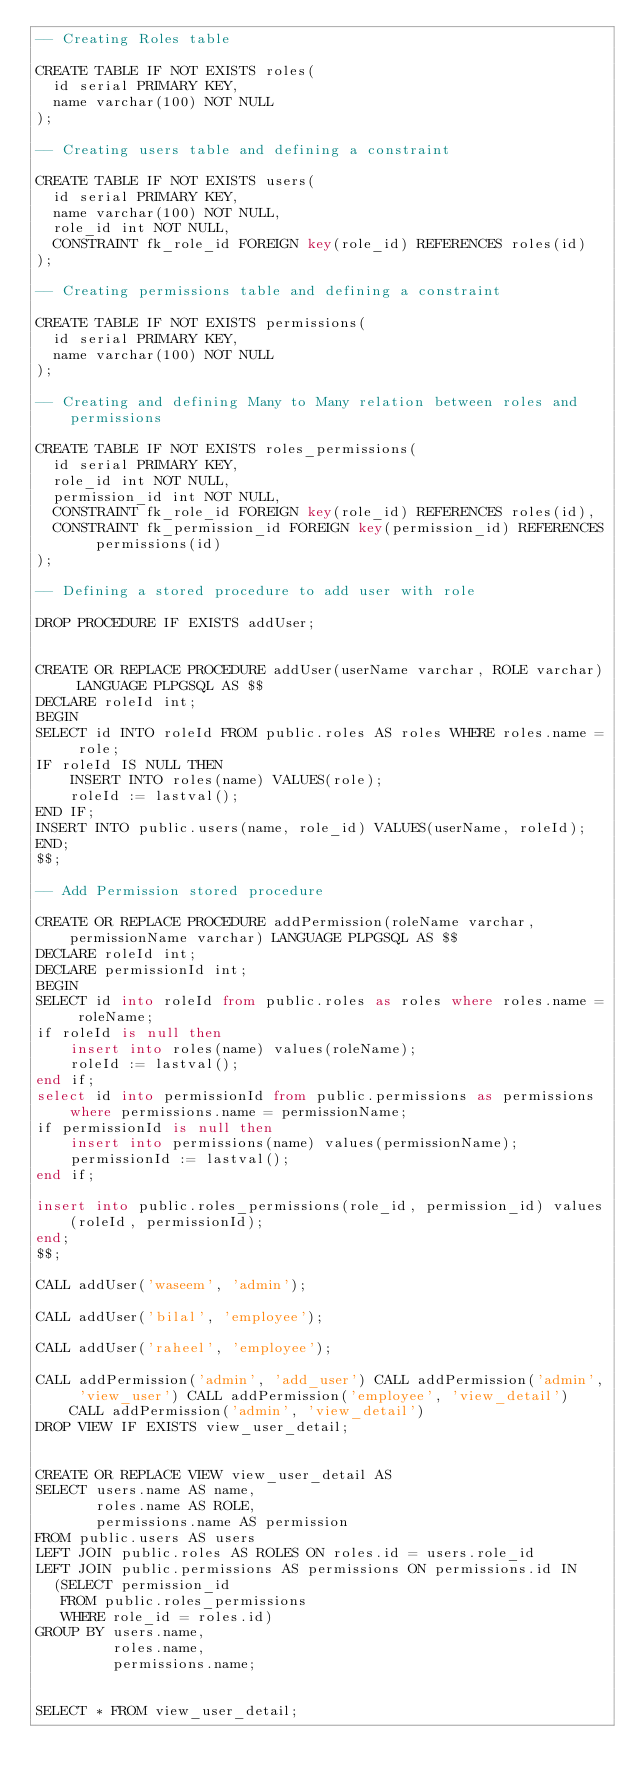Convert code to text. <code><loc_0><loc_0><loc_500><loc_500><_SQL_>-- Creating Roles table

CREATE TABLE IF NOT EXISTS roles(
  id serial PRIMARY KEY,
  name varchar(100) NOT NULL
);

-- Creating users table and defining a constraint

CREATE TABLE IF NOT EXISTS users(
  id serial PRIMARY KEY,
  name varchar(100) NOT NULL,
  role_id int NOT NULL,
  CONSTRAINT fk_role_id FOREIGN key(role_id) REFERENCES roles(id)
);

-- Creating permissions table and defining a constraint

CREATE TABLE IF NOT EXISTS permissions(
  id serial PRIMARY KEY,
  name varchar(100) NOT NULL
);

-- Creating and defining Many to Many relation between roles and permissions

CREATE TABLE IF NOT EXISTS roles_permissions(
  id serial PRIMARY KEY,
  role_id int NOT NULL,
  permission_id int NOT NULL,
  CONSTRAINT fk_role_id FOREIGN key(role_id) REFERENCES roles(id),
  CONSTRAINT fk_permission_id FOREIGN key(permission_id) REFERENCES permissions(id)
);

-- Defining a stored procedure to add user with role

DROP PROCEDURE IF EXISTS addUser;


CREATE OR REPLACE PROCEDURE addUser(userName varchar, ROLE varchar) LANGUAGE PLPGSQL AS $$
DECLARE roleId int;
BEGIN
SELECT id INTO roleId FROM public.roles AS roles WHERE roles.name = role;
IF roleId IS NULL THEN
	INSERT INTO roles(name) VALUES(role);
	roleId := lastval();
END IF;
INSERT INTO public.users(name, role_id) VALUES(userName, roleId);
END;
$$;

-- Add Permission stored procedure

CREATE OR REPLACE PROCEDURE addPermission(roleName varchar, permissionName varchar) LANGUAGE PLPGSQL AS $$
DECLARE roleId int;
DECLARE permissionId int;
BEGIN
SELECT id into roleId from public.roles as roles where roles.name = roleName;
if roleId is null then
	insert into roles(name) values(roleName);
	roleId := lastval();
end if;
select id into permissionId from public.permissions as permissions where permissions.name = permissionName;
if permissionId is null then
	insert into permissions(name) values(permissionName);
	permissionId := lastval();
end if;

insert into public.roles_permissions(role_id, permission_id) values(roleId, permissionId);
end;
$$;

CALL addUser('waseem', 'admin');

CALL addUser('bilal', 'employee');

CALL addUser('raheel', 'employee');

CALL addPermission('admin', 'add_user') CALL addPermission('admin', 'view_user') CALL addPermission('employee', 'view_detail') CALL addPermission('admin', 'view_detail')
DROP VIEW IF EXISTS view_user_detail;


CREATE OR REPLACE VIEW view_user_detail AS
SELECT users.name AS name,
       roles.name AS ROLE,
       permissions.name AS permission
FROM public.users AS users
LEFT JOIN public.roles AS ROLES ON roles.id = users.role_id
LEFT JOIN public.permissions AS permissions ON permissions.id IN
  (SELECT permission_id
   FROM public.roles_permissions
   WHERE role_id = roles.id)
GROUP BY users.name,
         roles.name,
         permissions.name;


SELECT * FROM view_user_detail;</code> 